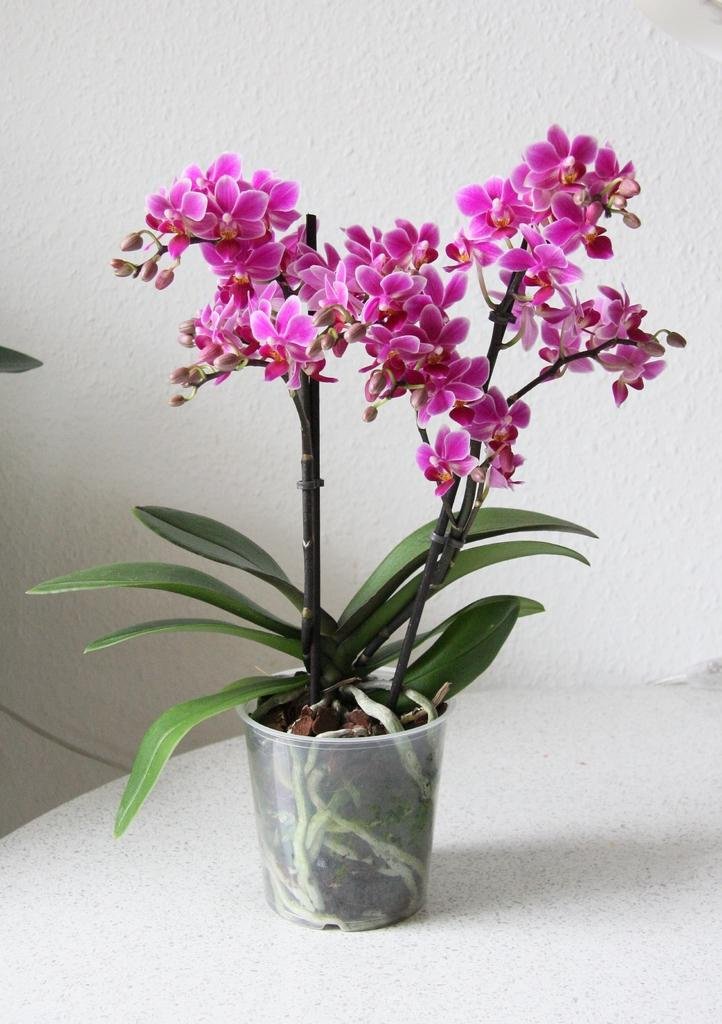What type of plant is in the image? There is a house plant in the image. What is the color of the surface the house plant is on? The house plant is on a white surface. What can be seen in the background of the image? There is a wall visible in the background of the image. What type of flower is your aunt holding in the image? There is no aunt or flower present in the image; it only features a house plant on a white surface with a wall visible in the background. 